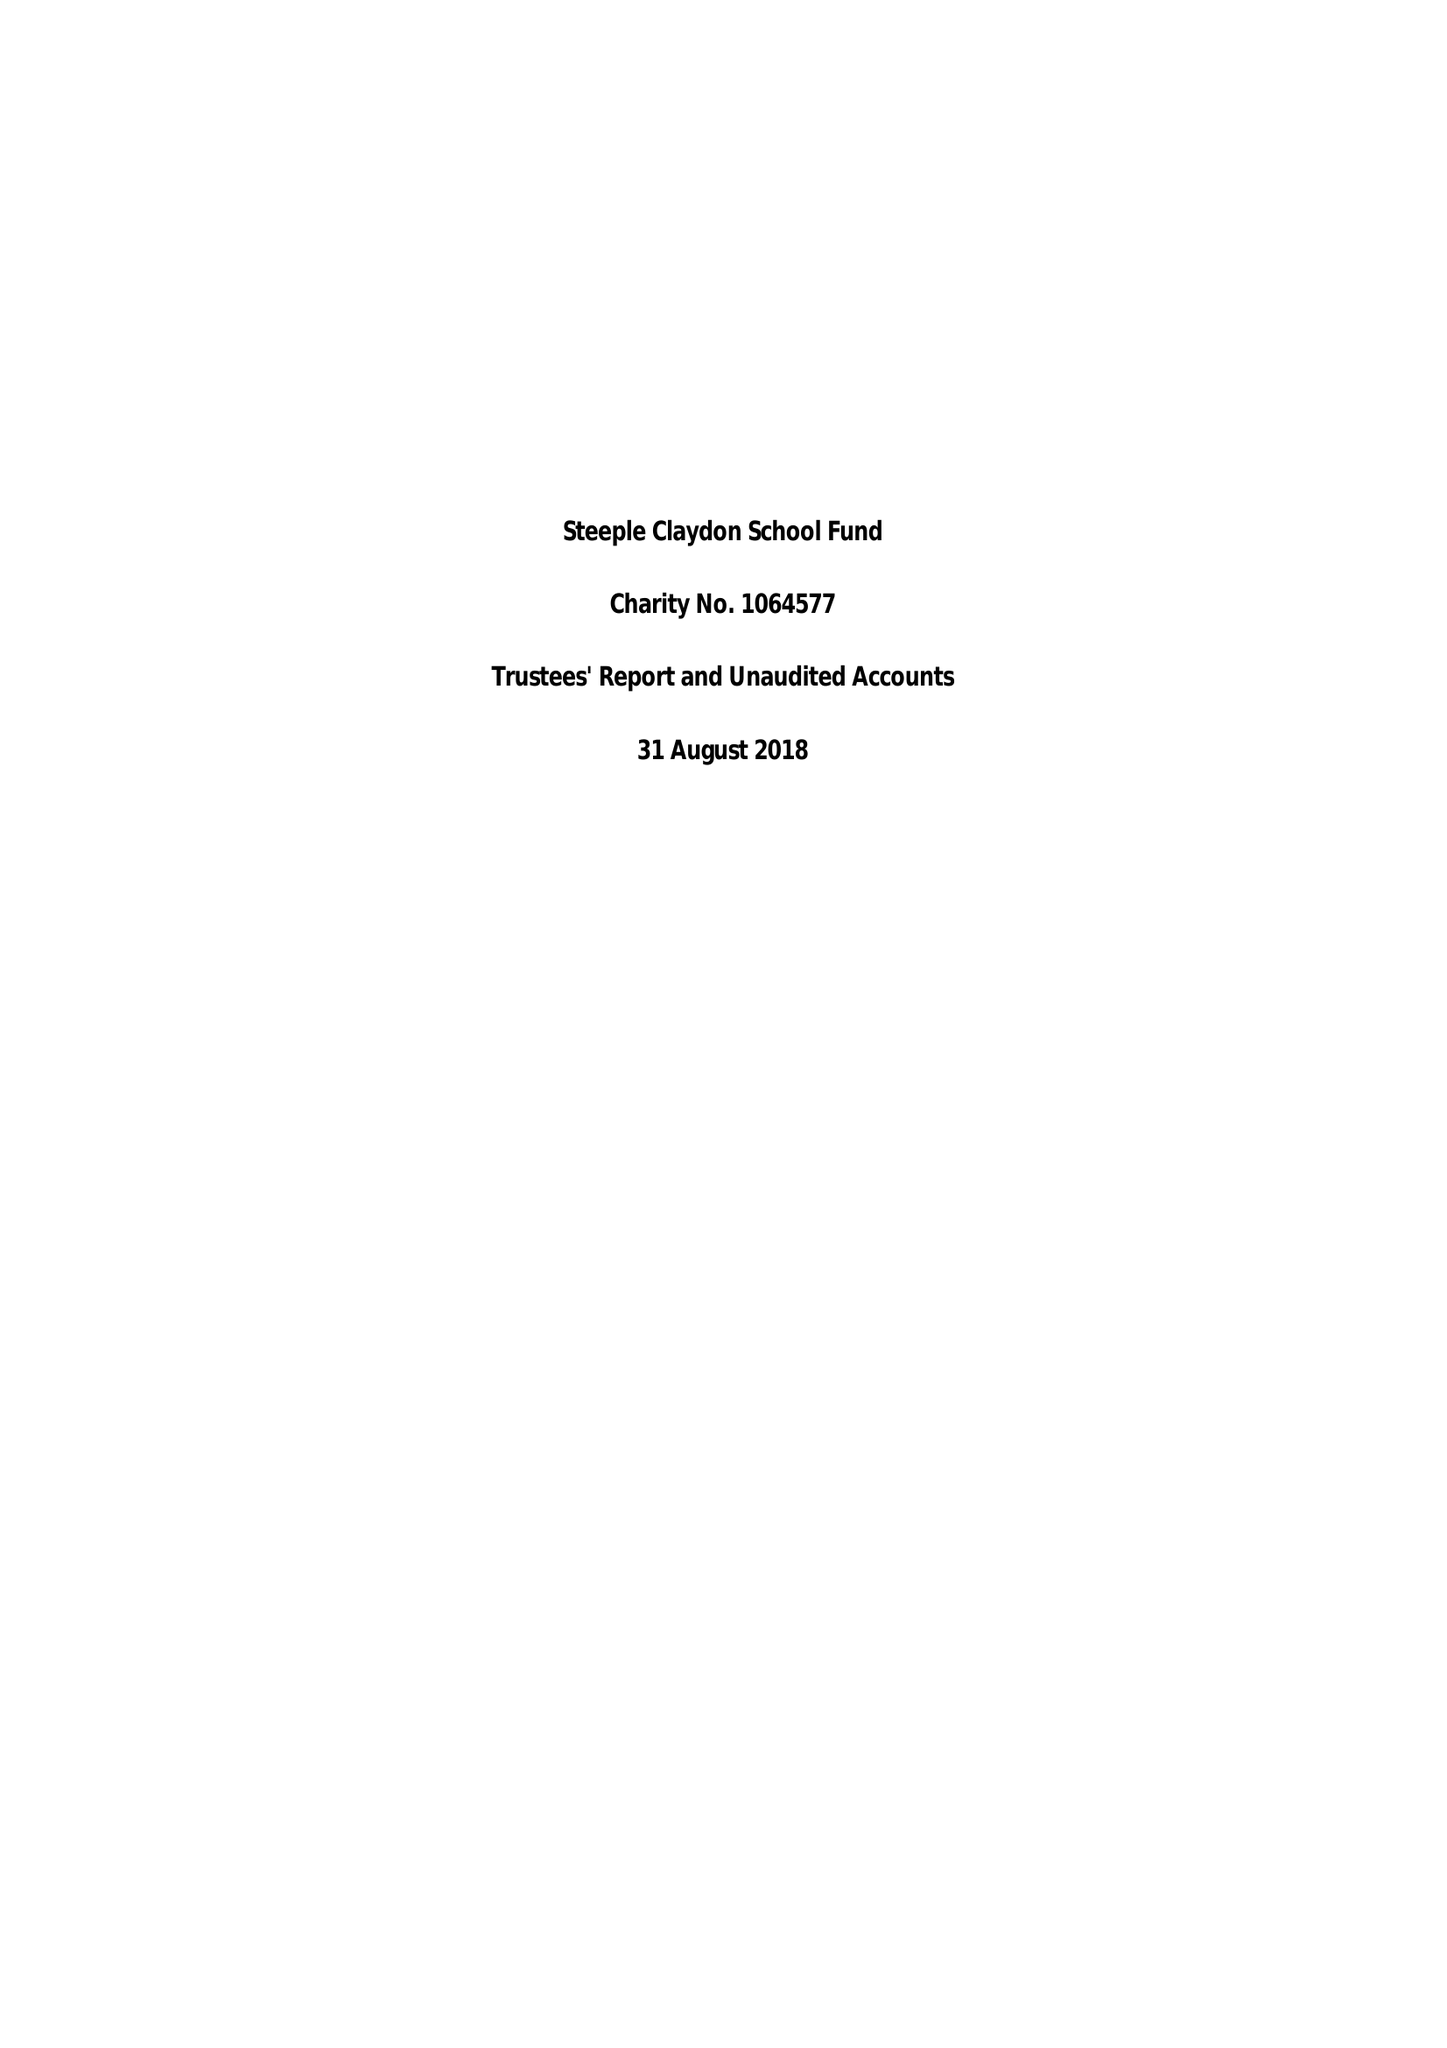What is the value for the address__street_line?
Answer the question using a single word or phrase. MEADOWAY 